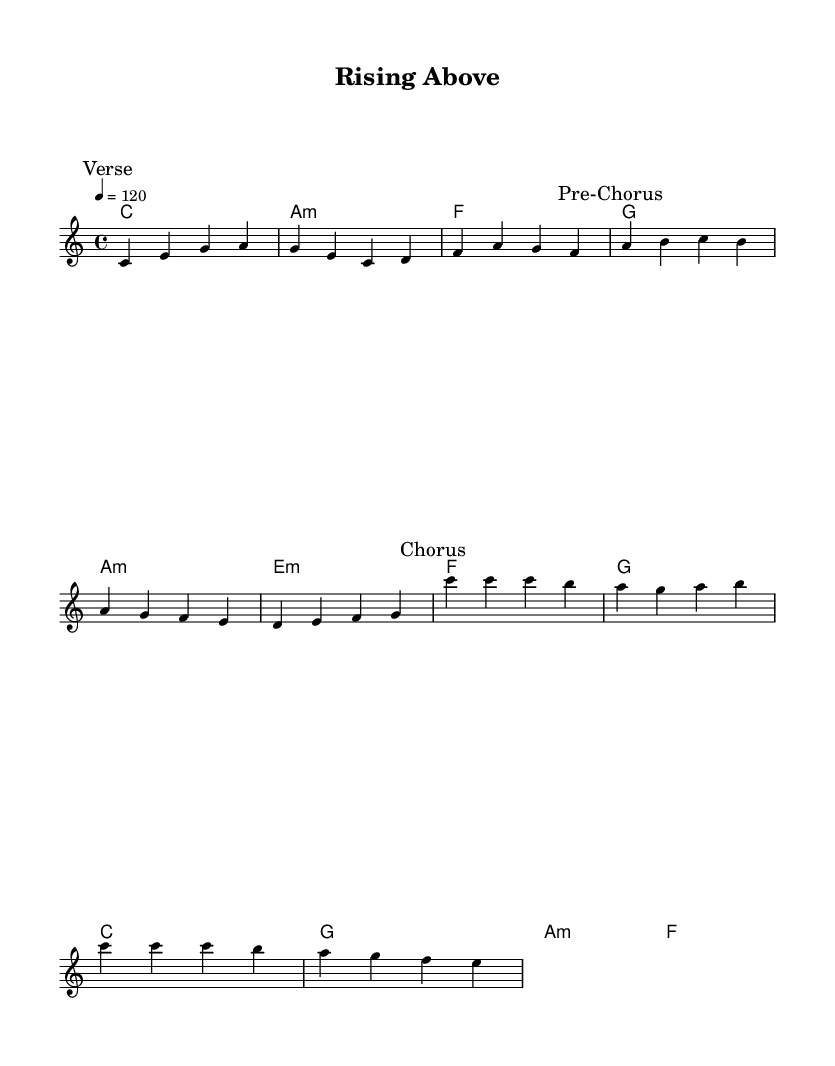What is the key signature of this music? The key signature is C major, which has no sharps or flats.
Answer: C major What is the time signature of this music? The time signature is indicated at the beginning of the score and shows that there are four beats per measure, commonly associated with dance music.
Answer: 4/4 What is the tempo marking for this piece? The tempo marking "4 = 120" indicates that there are 120 beats per minute, which is standard for upbeat dance music.
Answer: 120 How many sections does this composition have? The score includes a verse, pre-chorus, and chorus, making it a total of three distinct sections.
Answer: Three What is the first chord used in the verse? The first chord in the verse is shown at the beginning of the harmony section and it is labeled as "C major".
Answer: C In the chorus, what musical action is described in the lyrics? The lyrics describe moving beyond past struggles and enjoying life, which is a common theme in uplifting disco anthems.
Answer: Dancing What emotional theme does this anthem promote? The anthem promotes overcoming pain and struggles, conveyed through lyrics about rising above and breaking free, which is characteristic of uplifting disco music.
Answer: Overcoming struggles 